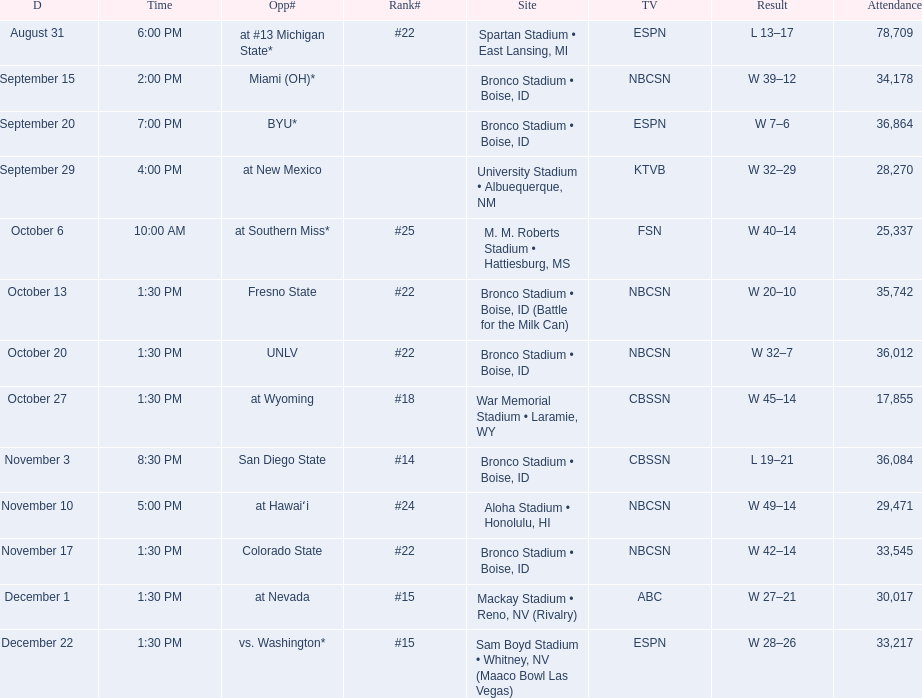What are the opponents to the  2012 boise state broncos football team? At #13 michigan state*, miami (oh)*, byu*, at new mexico, at southern miss*, fresno state, unlv, at wyoming, san diego state, at hawaiʻi, colorado state, at nevada, vs. washington*. Which is the highest ranked of the teams? San Diego State. 